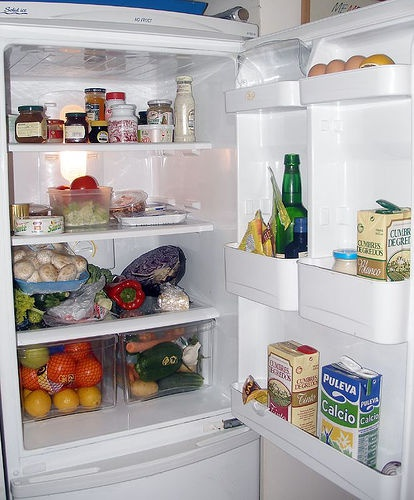Describe the objects in this image and their specific colors. I can see refrigerator in lightgray, darkgray, darkblue, gray, and black tones, bottle in navy, darkgreen, black, and olive tones, bottle in navy, darkgray, and lightgray tones, bottle in navy, maroon, black, and tan tones, and orange in navy, brown, maroon, and red tones in this image. 